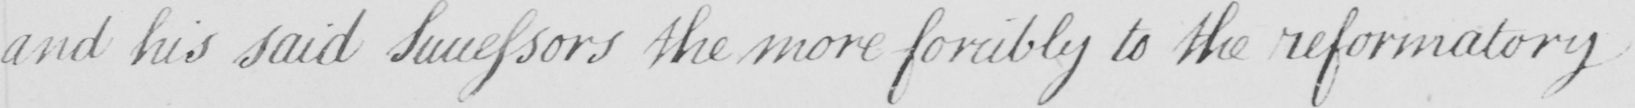Transcribe the text shown in this historical manuscript line. and his said Successors the more forcibly to the reformatory 